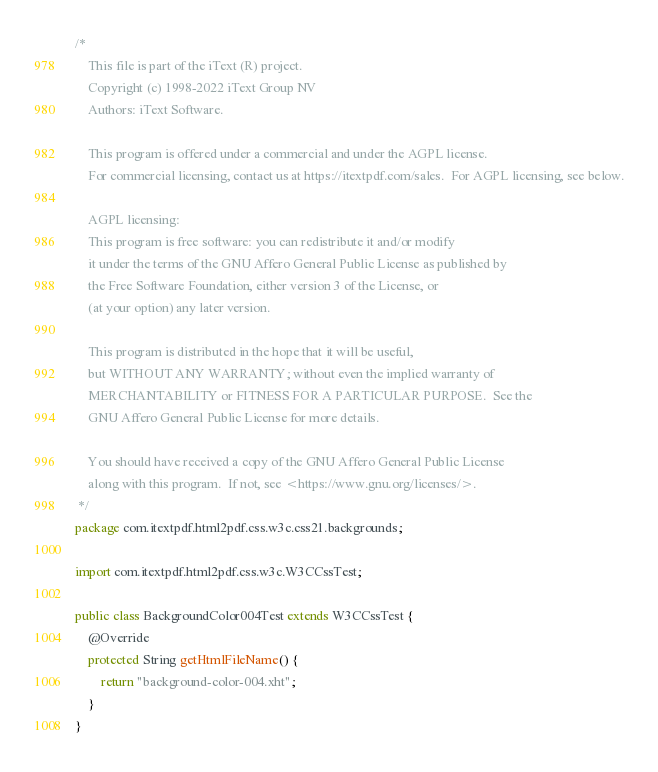Convert code to text. <code><loc_0><loc_0><loc_500><loc_500><_Java_>/*
    This file is part of the iText (R) project.
    Copyright (c) 1998-2022 iText Group NV
    Authors: iText Software.

    This program is offered under a commercial and under the AGPL license.
    For commercial licensing, contact us at https://itextpdf.com/sales.  For AGPL licensing, see below.

    AGPL licensing:
    This program is free software: you can redistribute it and/or modify
    it under the terms of the GNU Affero General Public License as published by
    the Free Software Foundation, either version 3 of the License, or
    (at your option) any later version.

    This program is distributed in the hope that it will be useful,
    but WITHOUT ANY WARRANTY; without even the implied warranty of
    MERCHANTABILITY or FITNESS FOR A PARTICULAR PURPOSE.  See the
    GNU Affero General Public License for more details.

    You should have received a copy of the GNU Affero General Public License
    along with this program.  If not, see <https://www.gnu.org/licenses/>.
 */
package com.itextpdf.html2pdf.css.w3c.css21.backgrounds;

import com.itextpdf.html2pdf.css.w3c.W3CCssTest;

public class BackgroundColor004Test extends W3CCssTest {
    @Override
    protected String getHtmlFileName() {
        return "background-color-004.xht";
    }
}
</code> 